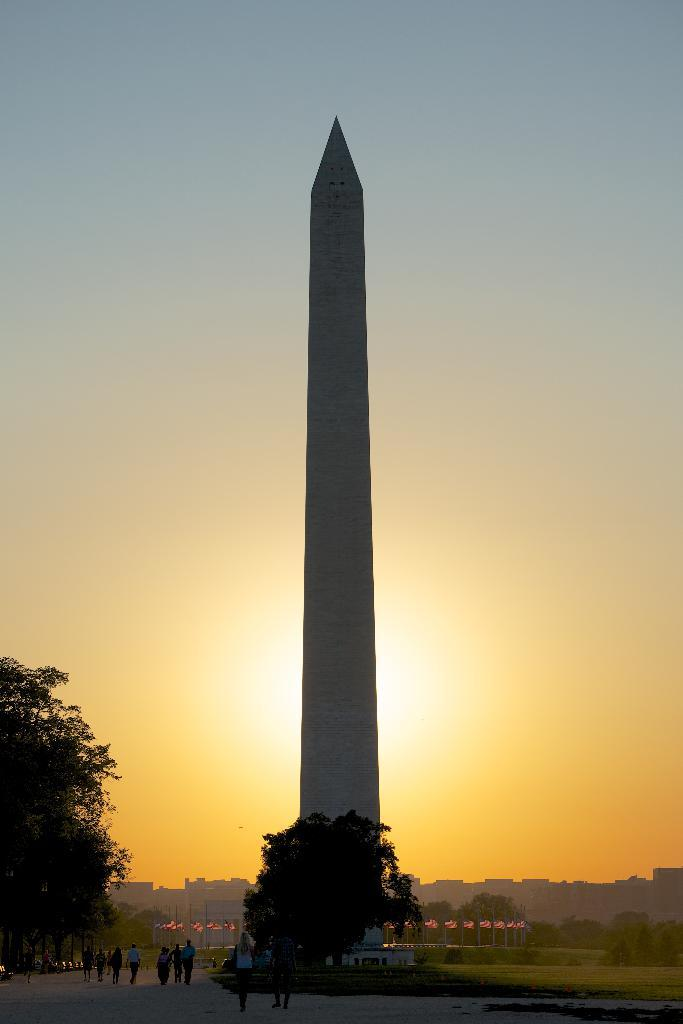What is the main structure in the image? There is a tower in the image. What type of vegetation can be seen in the image? There are trees, plants, and grass in the image. What are the poles used for in the image? The purpose of the poles is not specified in the image. Are there any people visible in the image? Yes, there are people at the bottom of the image. What is visible in the background of the image? The sky is visible in the background of the image. What type of dolls can be seen playing in the schoolyard in the image? There are no dolls or schoolyard present in the image. Is there any gold visible in the image? There is no gold present in the image. 